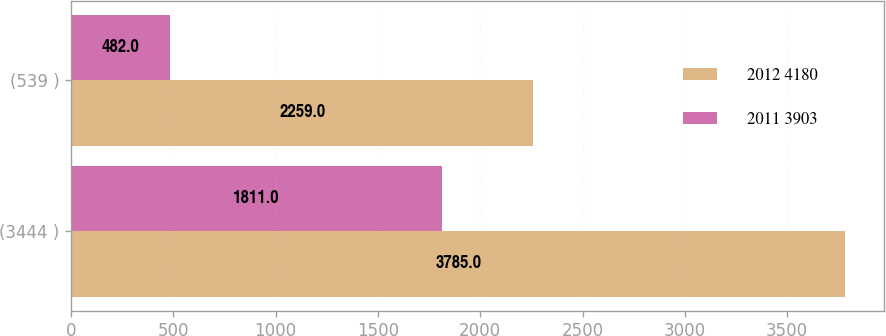<chart> <loc_0><loc_0><loc_500><loc_500><stacked_bar_chart><ecel><fcel>(3444 )<fcel>(539 )<nl><fcel>2012 4180<fcel>3785<fcel>2259<nl><fcel>2011 3903<fcel>1811<fcel>482<nl></chart> 